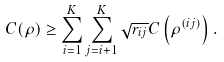<formula> <loc_0><loc_0><loc_500><loc_500>C ( \rho ) \geq \sum _ { i = 1 } ^ { K } \sum _ { j = i + 1 } ^ { K } \sqrt { r _ { i j } } C \left ( \rho ^ { ( i j ) } \right ) .</formula> 